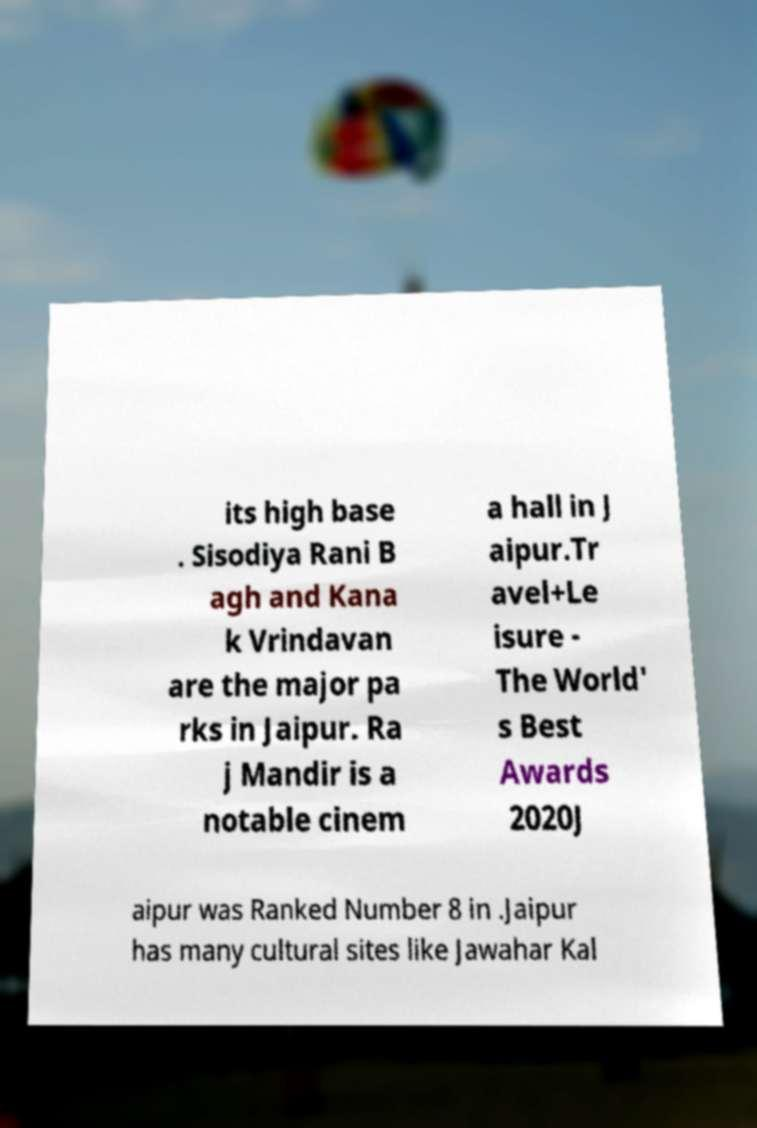Can you accurately transcribe the text from the provided image for me? its high base . Sisodiya Rani B agh and Kana k Vrindavan are the major pa rks in Jaipur. Ra j Mandir is a notable cinem a hall in J aipur.Tr avel+Le isure - The World' s Best Awards 2020J aipur was Ranked Number 8 in .Jaipur has many cultural sites like Jawahar Kal 